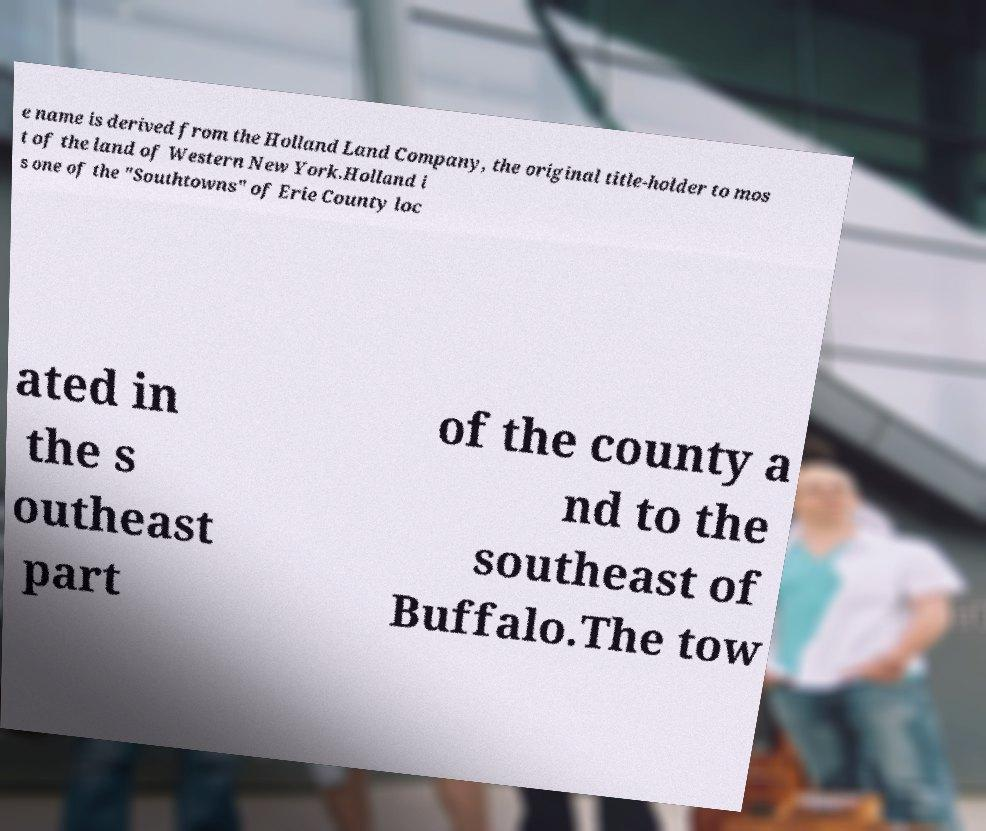I need the written content from this picture converted into text. Can you do that? e name is derived from the Holland Land Company, the original title-holder to mos t of the land of Western New York.Holland i s one of the "Southtowns" of Erie County loc ated in the s outheast part of the county a nd to the southeast of Buffalo.The tow 